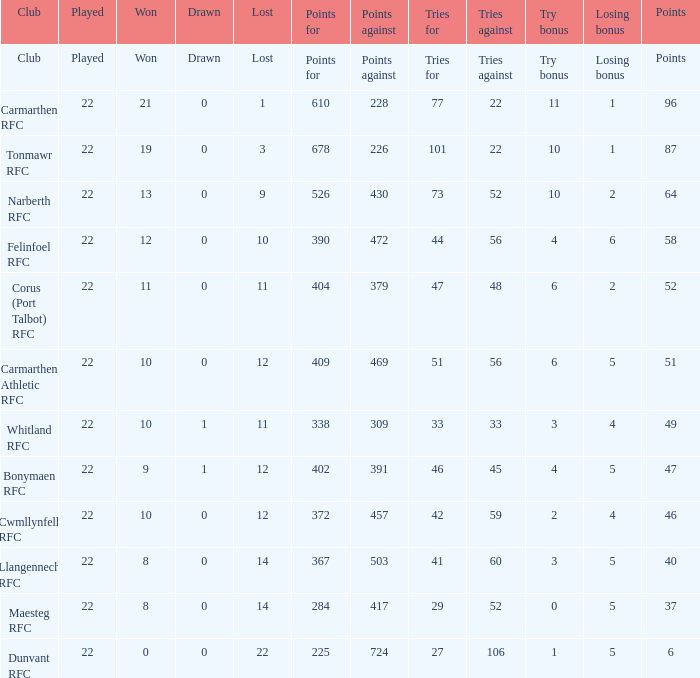List the efforts made to reach 87 points. 22.0. 